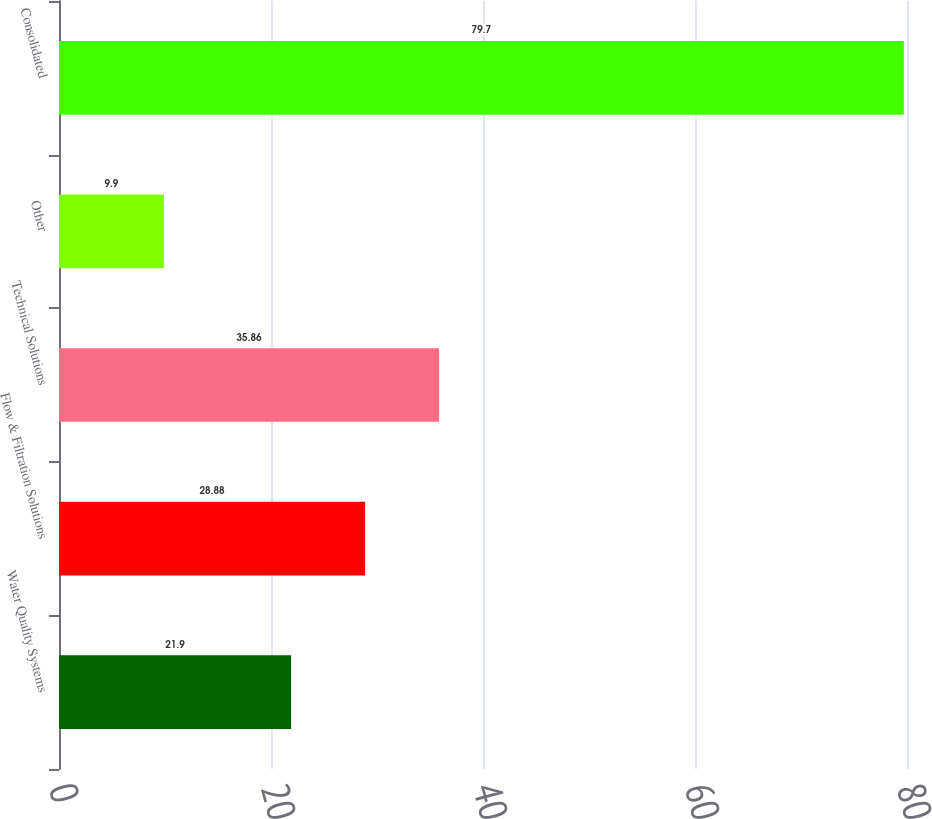Convert chart to OTSL. <chart><loc_0><loc_0><loc_500><loc_500><bar_chart><fcel>Water Quality Systems<fcel>Flow & Filtration Solutions<fcel>Technical Solutions<fcel>Other<fcel>Consolidated<nl><fcel>21.9<fcel>28.88<fcel>35.86<fcel>9.9<fcel>79.7<nl></chart> 